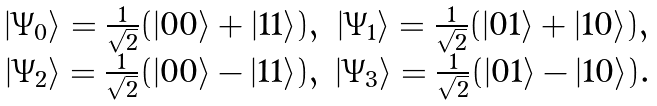<formula> <loc_0><loc_0><loc_500><loc_500>\begin{array} { c c } | \Psi _ { 0 } \rangle = \frac { 1 } { \sqrt { 2 } } ( | 0 0 \rangle + | 1 1 \rangle ) , & | \Psi _ { 1 } \rangle = \frac { 1 } { \sqrt { 2 } } ( | 0 1 \rangle + | 1 0 \rangle ) , \\ | \Psi _ { 2 } \rangle = \frac { 1 } { \sqrt { 2 } } ( | 0 0 \rangle - | 1 1 \rangle ) , & | \Psi _ { 3 } \rangle = \frac { 1 } { \sqrt { 2 } } ( | 0 1 \rangle - | 1 0 \rangle ) . \\ \end{array}</formula> 